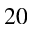Convert formula to latex. <formula><loc_0><loc_0><loc_500><loc_500>2 0</formula> 